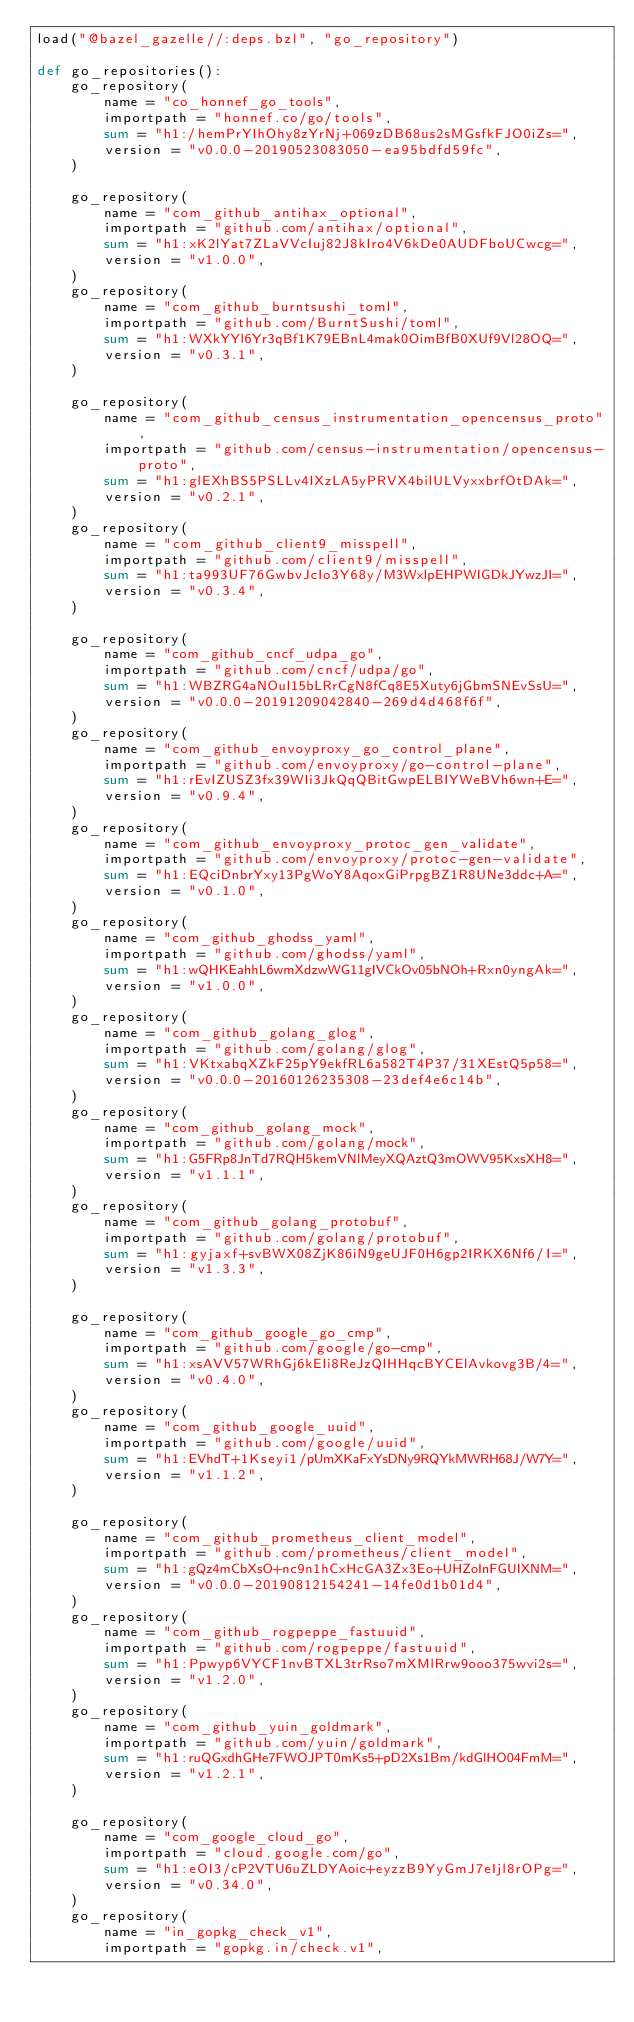<code> <loc_0><loc_0><loc_500><loc_500><_Python_>load("@bazel_gazelle//:deps.bzl", "go_repository")

def go_repositories():
    go_repository(
        name = "co_honnef_go_tools",
        importpath = "honnef.co/go/tools",
        sum = "h1:/hemPrYIhOhy8zYrNj+069zDB68us2sMGsfkFJO0iZs=",
        version = "v0.0.0-20190523083050-ea95bdfd59fc",
    )

    go_repository(
        name = "com_github_antihax_optional",
        importpath = "github.com/antihax/optional",
        sum = "h1:xK2lYat7ZLaVVcIuj82J8kIro4V6kDe0AUDFboUCwcg=",
        version = "v1.0.0",
    )
    go_repository(
        name = "com_github_burntsushi_toml",
        importpath = "github.com/BurntSushi/toml",
        sum = "h1:WXkYYl6Yr3qBf1K79EBnL4mak0OimBfB0XUf9Vl28OQ=",
        version = "v0.3.1",
    )

    go_repository(
        name = "com_github_census_instrumentation_opencensus_proto",
        importpath = "github.com/census-instrumentation/opencensus-proto",
        sum = "h1:glEXhBS5PSLLv4IXzLA5yPRVX4bilULVyxxbrfOtDAk=",
        version = "v0.2.1",
    )
    go_repository(
        name = "com_github_client9_misspell",
        importpath = "github.com/client9/misspell",
        sum = "h1:ta993UF76GwbvJcIo3Y68y/M3WxlpEHPWIGDkJYwzJI=",
        version = "v0.3.4",
    )

    go_repository(
        name = "com_github_cncf_udpa_go",
        importpath = "github.com/cncf/udpa/go",
        sum = "h1:WBZRG4aNOuI15bLRrCgN8fCq8E5Xuty6jGbmSNEvSsU=",
        version = "v0.0.0-20191209042840-269d4d468f6f",
    )
    go_repository(
        name = "com_github_envoyproxy_go_control_plane",
        importpath = "github.com/envoyproxy/go-control-plane",
        sum = "h1:rEvIZUSZ3fx39WIi3JkQqQBitGwpELBIYWeBVh6wn+E=",
        version = "v0.9.4",
    )
    go_repository(
        name = "com_github_envoyproxy_protoc_gen_validate",
        importpath = "github.com/envoyproxy/protoc-gen-validate",
        sum = "h1:EQciDnbrYxy13PgWoY8AqoxGiPrpgBZ1R8UNe3ddc+A=",
        version = "v0.1.0",
    )
    go_repository(
        name = "com_github_ghodss_yaml",
        importpath = "github.com/ghodss/yaml",
        sum = "h1:wQHKEahhL6wmXdzwWG11gIVCkOv05bNOh+Rxn0yngAk=",
        version = "v1.0.0",
    )
    go_repository(
        name = "com_github_golang_glog",
        importpath = "github.com/golang/glog",
        sum = "h1:VKtxabqXZkF25pY9ekfRL6a582T4P37/31XEstQ5p58=",
        version = "v0.0.0-20160126235308-23def4e6c14b",
    )
    go_repository(
        name = "com_github_golang_mock",
        importpath = "github.com/golang/mock",
        sum = "h1:G5FRp8JnTd7RQH5kemVNlMeyXQAztQ3mOWV95KxsXH8=",
        version = "v1.1.1",
    )
    go_repository(
        name = "com_github_golang_protobuf",
        importpath = "github.com/golang/protobuf",
        sum = "h1:gyjaxf+svBWX08ZjK86iN9geUJF0H6gp2IRKX6Nf6/I=",
        version = "v1.3.3",
    )

    go_repository(
        name = "com_github_google_go_cmp",
        importpath = "github.com/google/go-cmp",
        sum = "h1:xsAVV57WRhGj6kEIi8ReJzQlHHqcBYCElAvkovg3B/4=",
        version = "v0.4.0",
    )
    go_repository(
        name = "com_github_google_uuid",
        importpath = "github.com/google/uuid",
        sum = "h1:EVhdT+1Kseyi1/pUmXKaFxYsDNy9RQYkMWRH68J/W7Y=",
        version = "v1.1.2",
    )

    go_repository(
        name = "com_github_prometheus_client_model",
        importpath = "github.com/prometheus/client_model",
        sum = "h1:gQz4mCbXsO+nc9n1hCxHcGA3Zx3Eo+UHZoInFGUIXNM=",
        version = "v0.0.0-20190812154241-14fe0d1b01d4",
    )
    go_repository(
        name = "com_github_rogpeppe_fastuuid",
        importpath = "github.com/rogpeppe/fastuuid",
        sum = "h1:Ppwyp6VYCF1nvBTXL3trRso7mXMlRrw9ooo375wvi2s=",
        version = "v1.2.0",
    )
    go_repository(
        name = "com_github_yuin_goldmark",
        importpath = "github.com/yuin/goldmark",
        sum = "h1:ruQGxdhGHe7FWOJPT0mKs5+pD2Xs1Bm/kdGlHO04FmM=",
        version = "v1.2.1",
    )

    go_repository(
        name = "com_google_cloud_go",
        importpath = "cloud.google.com/go",
        sum = "h1:eOI3/cP2VTU6uZLDYAoic+eyzzB9YyGmJ7eIjl8rOPg=",
        version = "v0.34.0",
    )
    go_repository(
        name = "in_gopkg_check_v1",
        importpath = "gopkg.in/check.v1",</code> 